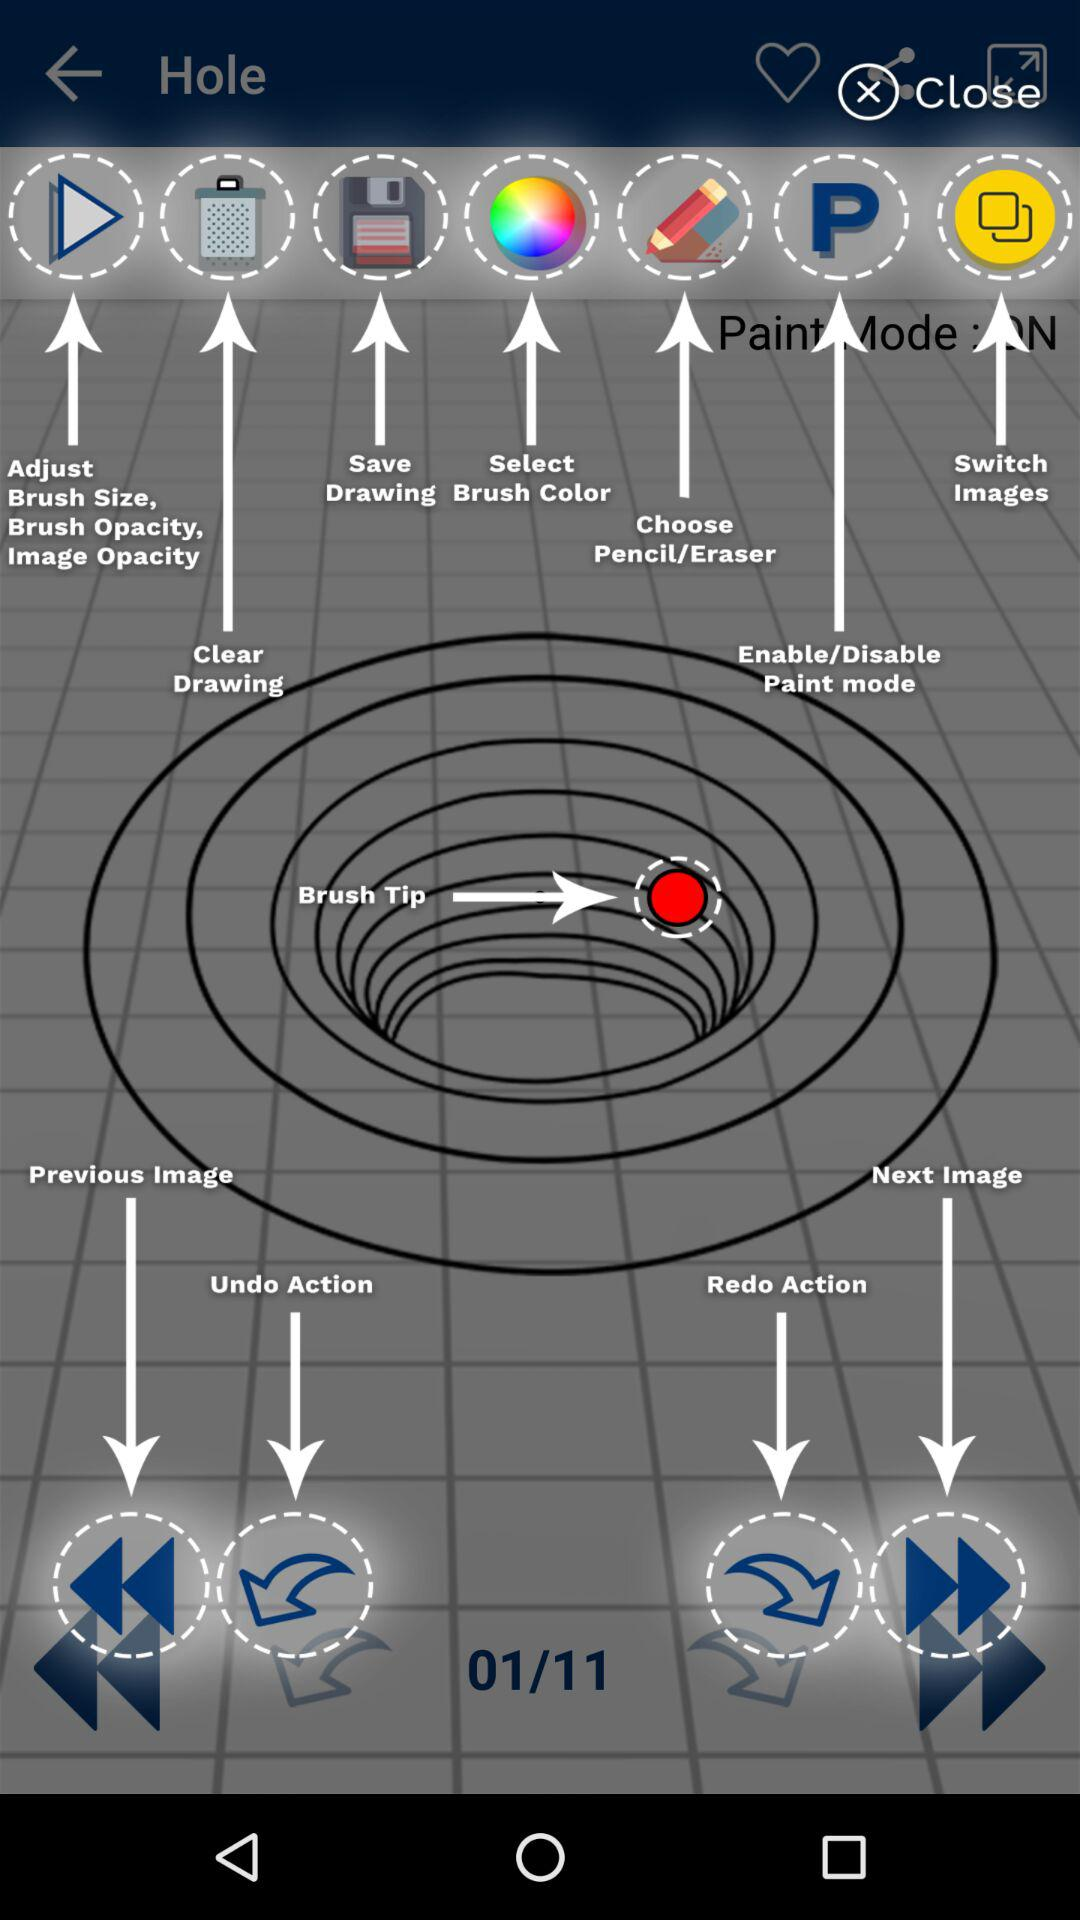What is the status of the "Paint Mode"? The status is "on". 